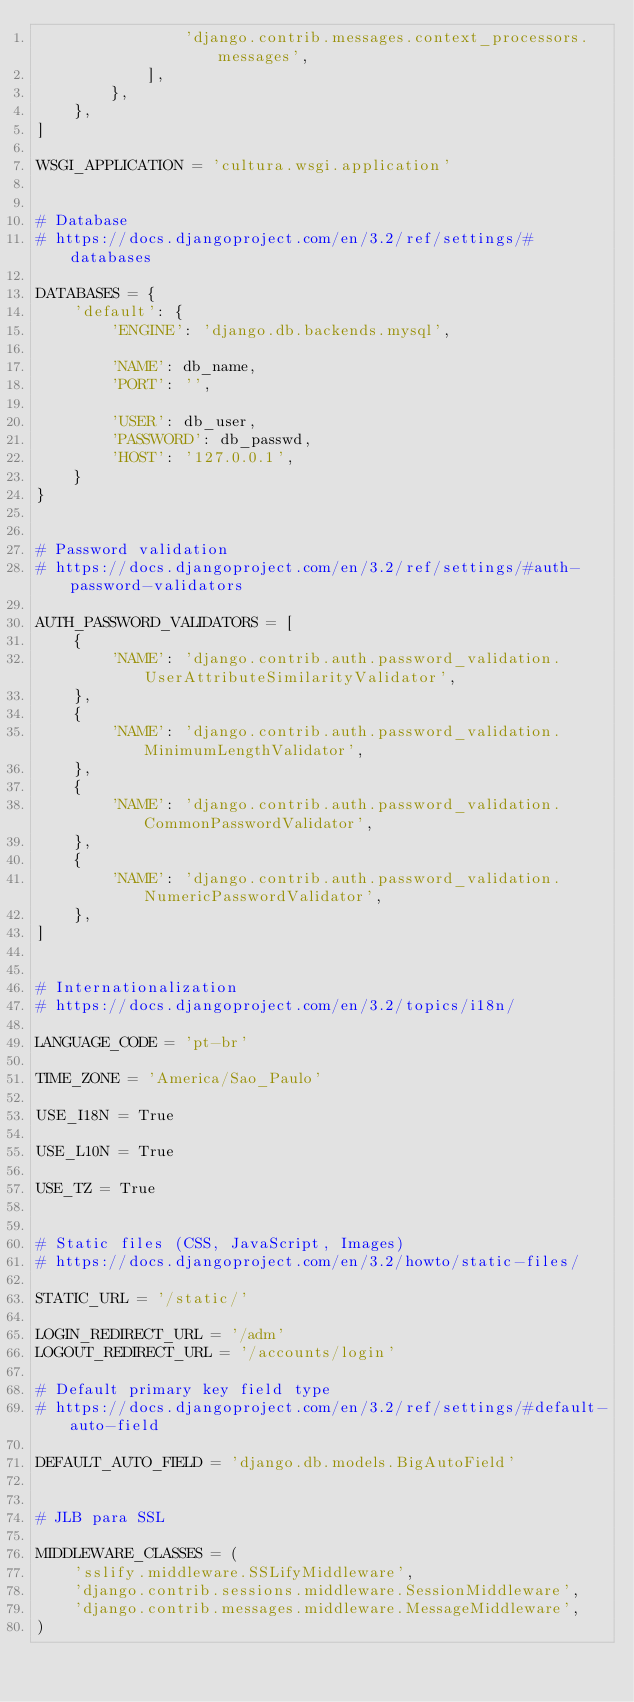<code> <loc_0><loc_0><loc_500><loc_500><_Python_>                'django.contrib.messages.context_processors.messages',
            ],
        },
    },
]

WSGI_APPLICATION = 'cultura.wsgi.application'


# Database
# https://docs.djangoproject.com/en/3.2/ref/settings/#databases

DATABASES = {
    'default': {
        'ENGINE': 'django.db.backends.mysql',

        'NAME': db_name,
        'PORT': '',

        'USER': db_user,
        'PASSWORD': db_passwd,
        'HOST': '127.0.0.1',
    }
}


# Password validation
# https://docs.djangoproject.com/en/3.2/ref/settings/#auth-password-validators

AUTH_PASSWORD_VALIDATORS = [
    {
        'NAME': 'django.contrib.auth.password_validation.UserAttributeSimilarityValidator',
    },
    {
        'NAME': 'django.contrib.auth.password_validation.MinimumLengthValidator',
    },
    {
        'NAME': 'django.contrib.auth.password_validation.CommonPasswordValidator',
    },
    {
        'NAME': 'django.contrib.auth.password_validation.NumericPasswordValidator',
    },
]


# Internationalization
# https://docs.djangoproject.com/en/3.2/topics/i18n/

LANGUAGE_CODE = 'pt-br'

TIME_ZONE = 'America/Sao_Paulo'

USE_I18N = True

USE_L10N = True

USE_TZ = True


# Static files (CSS, JavaScript, Images)
# https://docs.djangoproject.com/en/3.2/howto/static-files/

STATIC_URL = '/static/'

LOGIN_REDIRECT_URL = '/adm'
LOGOUT_REDIRECT_URL = '/accounts/login'

# Default primary key field type
# https://docs.djangoproject.com/en/3.2/ref/settings/#default-auto-field

DEFAULT_AUTO_FIELD = 'django.db.models.BigAutoField'


# JLB para SSL

MIDDLEWARE_CLASSES = (
    'sslify.middleware.SSLifyMiddleware',
    'django.contrib.sessions.middleware.SessionMiddleware',
    'django.contrib.messages.middleware.MessageMiddleware',
)
</code> 